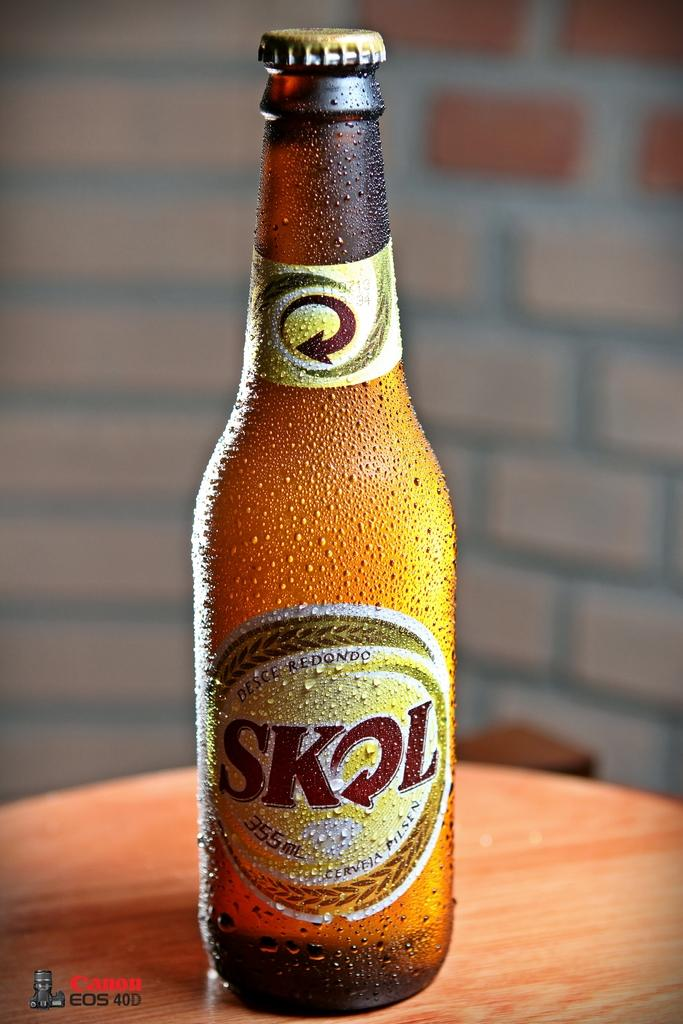<image>
Share a concise interpretation of the image provided. A very chilled SKL 355ml dark bottle with cap 